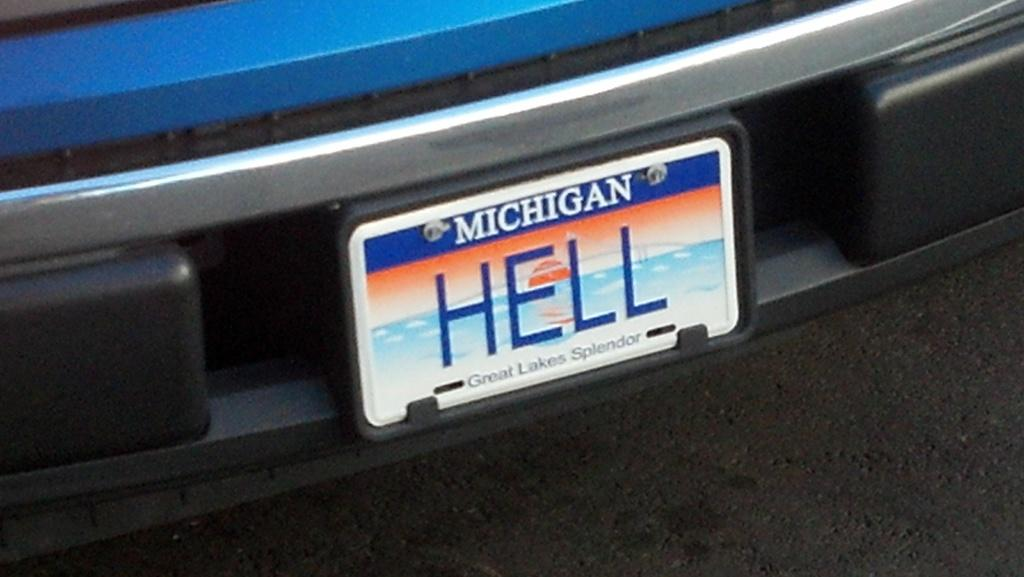<image>
Write a terse but informative summary of the picture. Blue and white Michigan license plate that says HELL on it. 